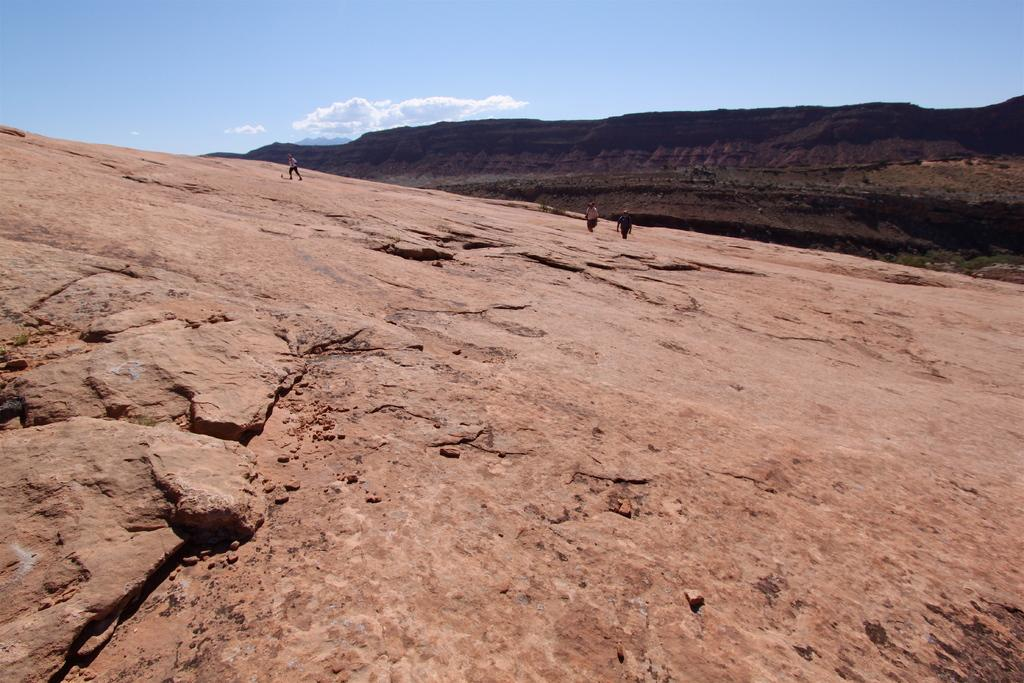How many people are in the image? There are three persons in the image. What is the rock used for in the image? The rock's purpose is not specified in the image. What is the large landform in the image? There is a mountain in the image. What can be seen in the background of the image? The sky is visible in the background of the image, and there are clouds in the sky. What invention is being celebrated on the person's birthday in the image? There is no mention of a birthday or invention in the image. 